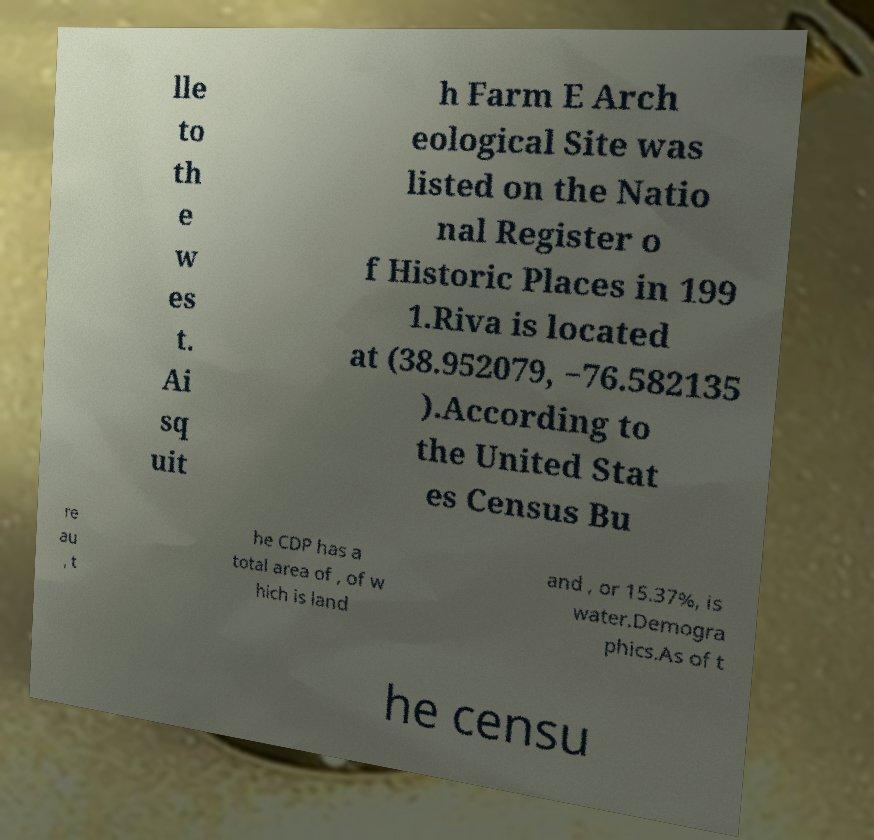Can you accurately transcribe the text from the provided image for me? lle to th e w es t. Ai sq uit h Farm E Arch eological Site was listed on the Natio nal Register o f Historic Places in 199 1.Riva is located at (38.952079, −76.582135 ).According to the United Stat es Census Bu re au , t he CDP has a total area of , of w hich is land and , or 15.37%, is water.Demogra phics.As of t he censu 